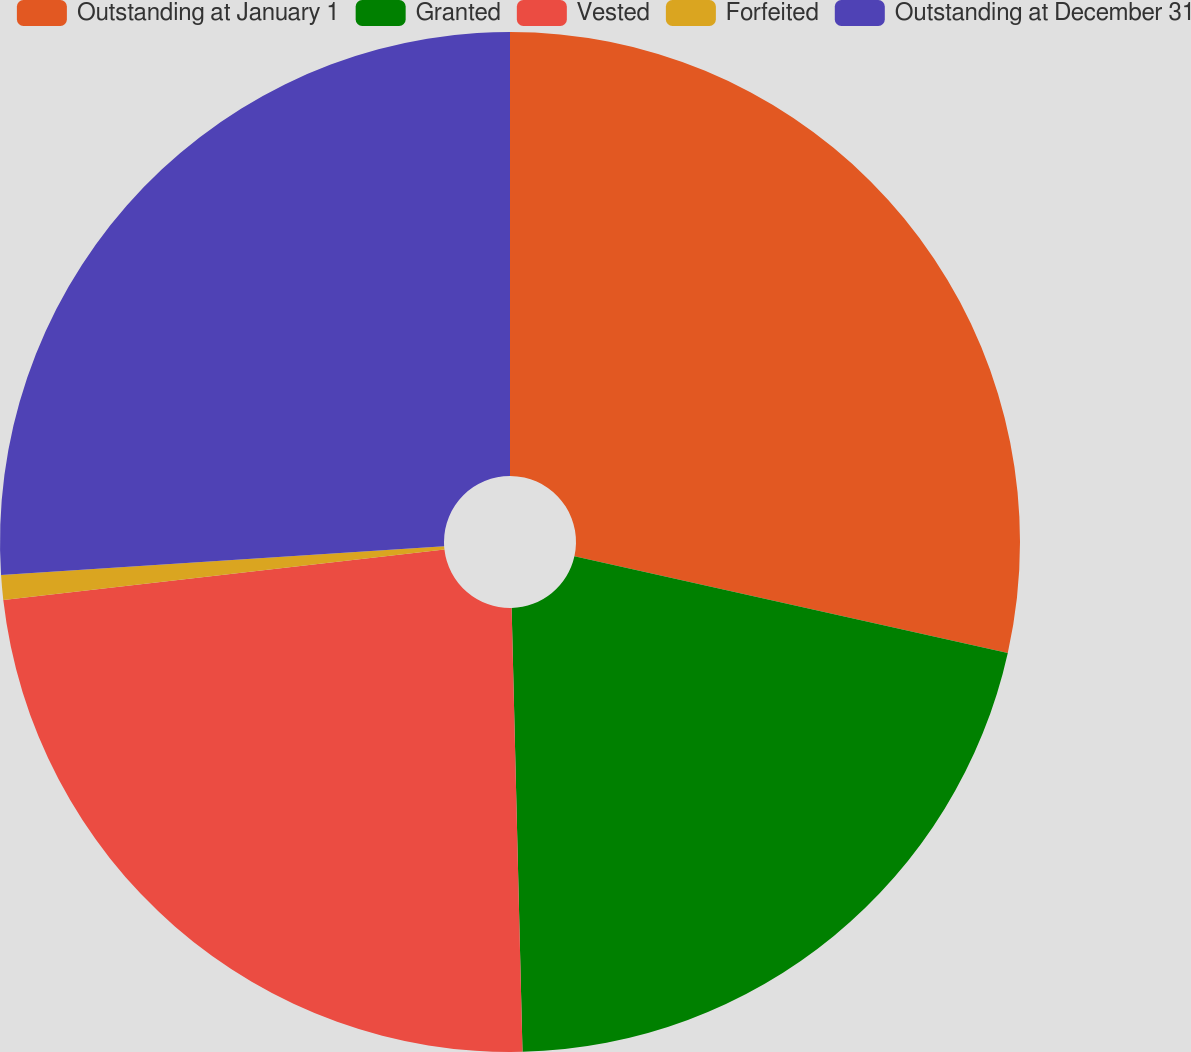Convert chart. <chart><loc_0><loc_0><loc_500><loc_500><pie_chart><fcel>Outstanding at January 1<fcel>Granted<fcel>Vested<fcel>Forfeited<fcel>Outstanding at December 31<nl><fcel>28.49%<fcel>21.12%<fcel>23.58%<fcel>0.78%<fcel>26.03%<nl></chart> 